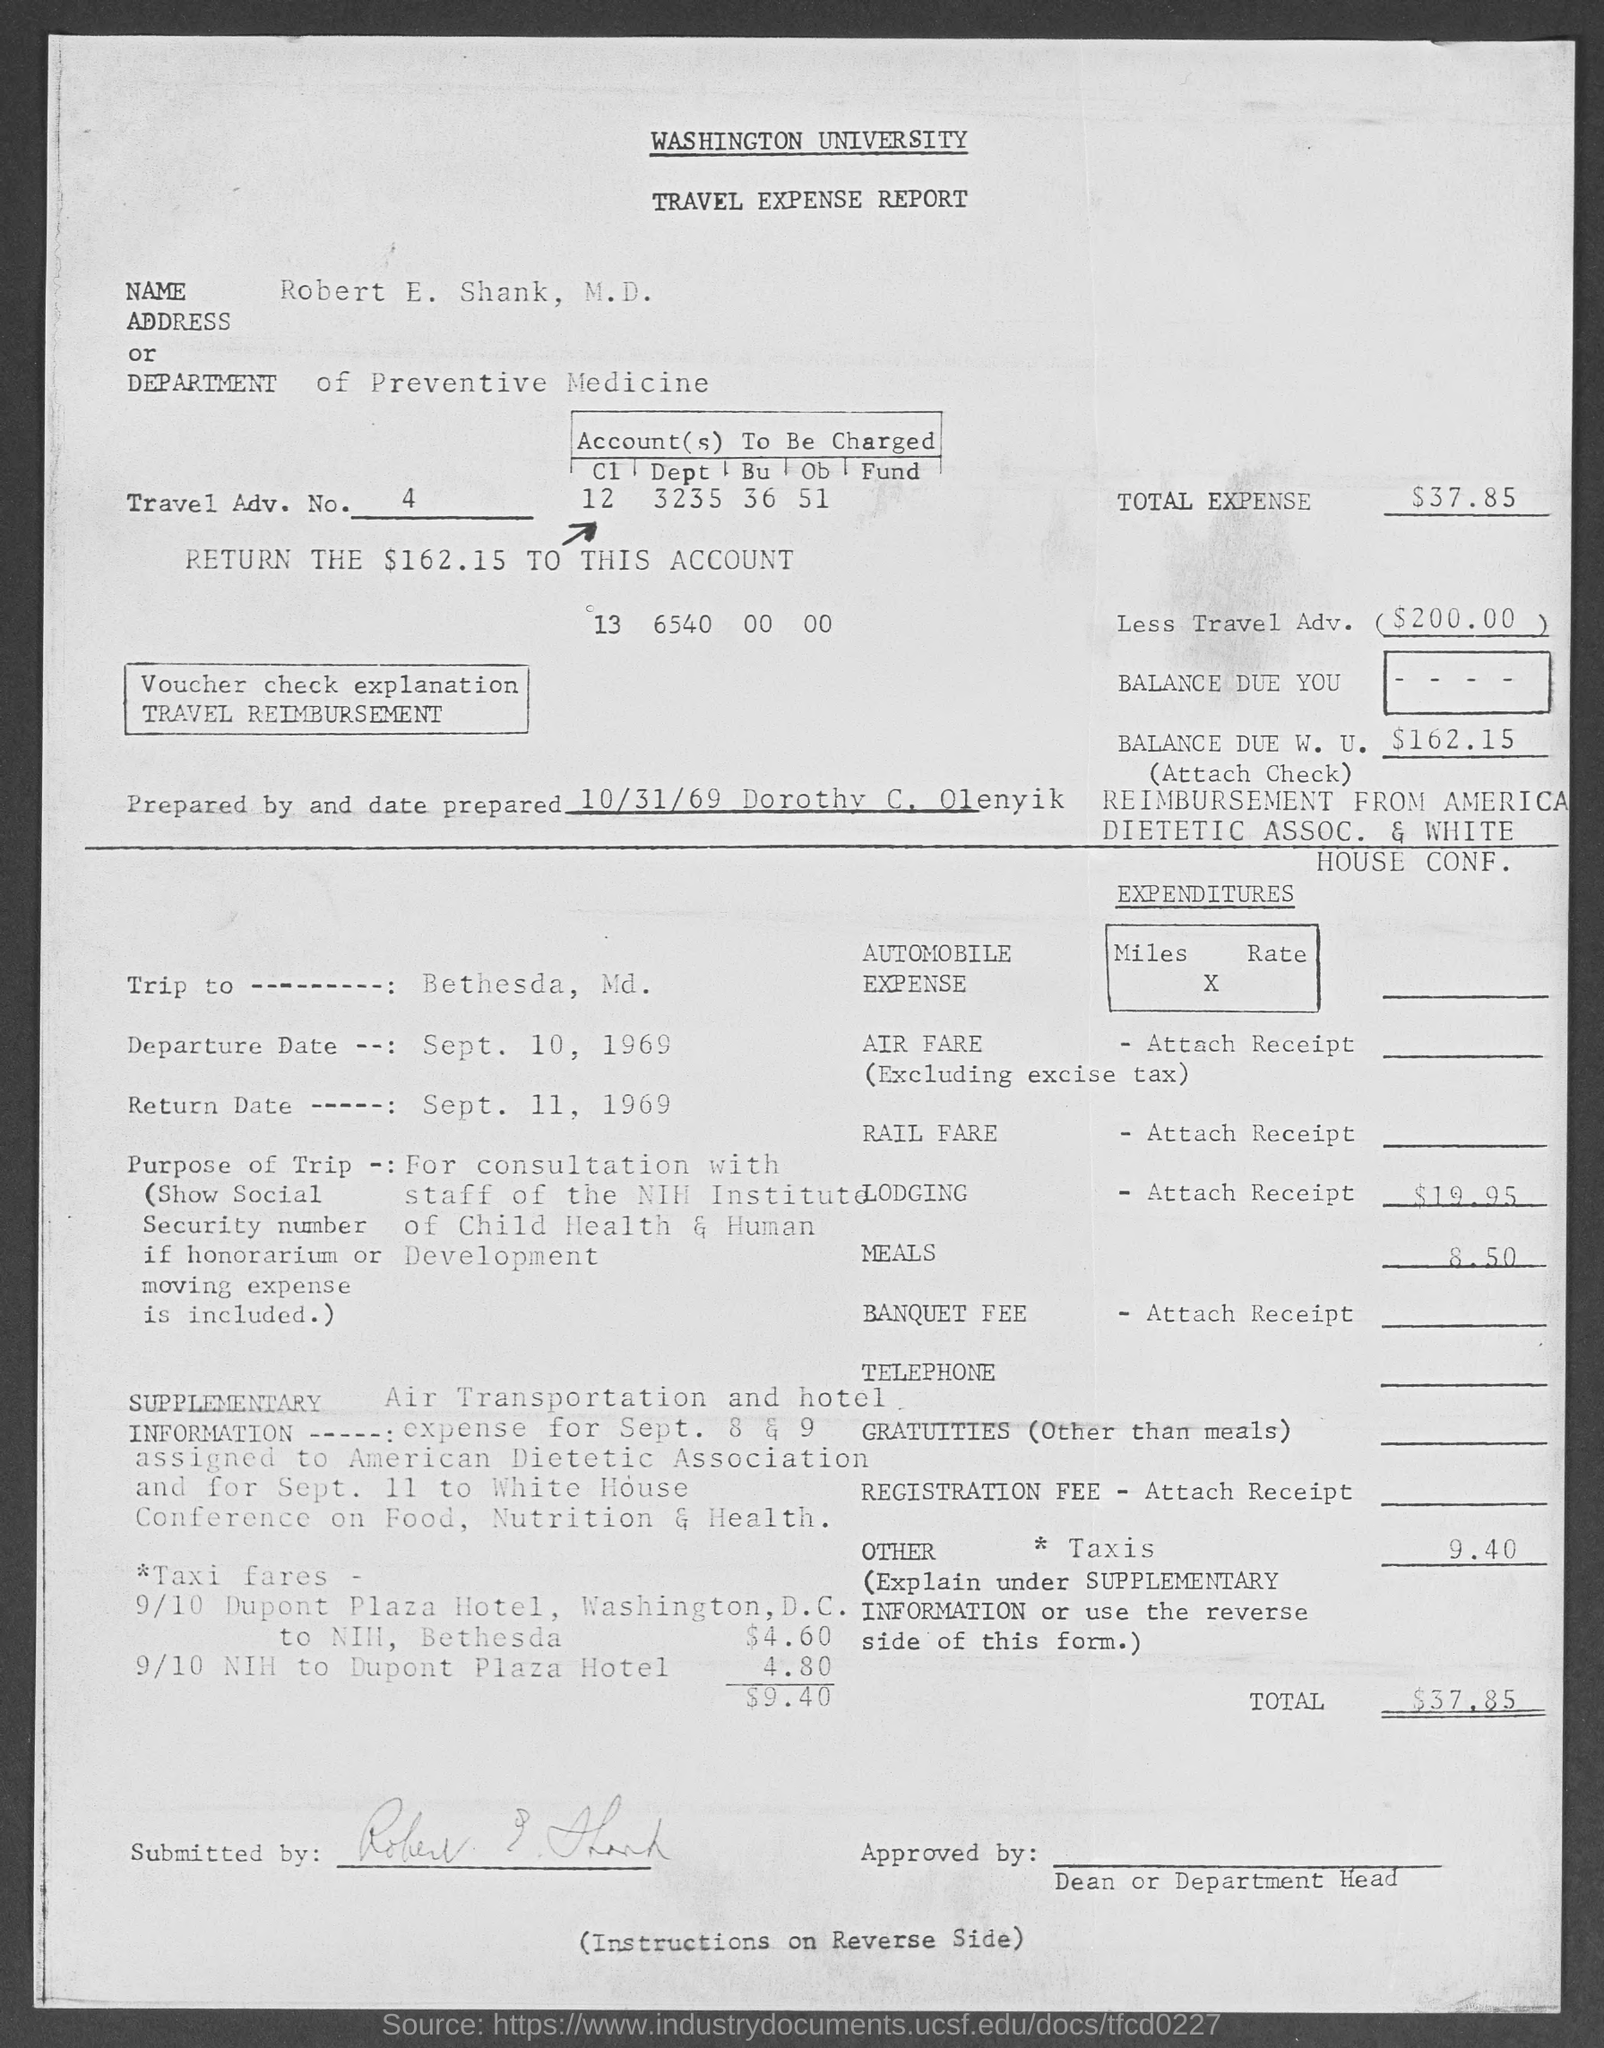In which deparment, Robert E. Shank, M.D. works?
Offer a terse response. DEPARTMENT of Preventive Medicine. What is the travel adv. no. given in the report?
Give a very brief answer. 4. What is the total expense mentioned in the travel expense report?
Offer a very short reply. $37.85. Who prepared the travel expense report?
Your answer should be compact. Dorothy C. Olenyik. What date the travel expense report is prepared?
Make the answer very short. 10/31/69. What is the Departure date mentioned in the travel expense report?
Ensure brevity in your answer.  SEPT. 10, 1969. What is the purpose of the trip of Robert E. Shank,  M.D.?
Provide a succinct answer. For consultation with staff of the NIH Institute of Child Health & Human Development. 